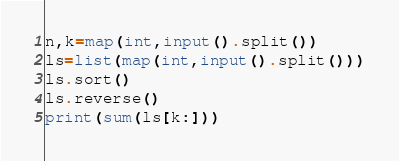Convert code to text. <code><loc_0><loc_0><loc_500><loc_500><_Python_>n,k=map(int,input().split())
ls=list(map(int,input().split()))
ls.sort()
ls.reverse()
print(sum(ls[k:]))
</code> 